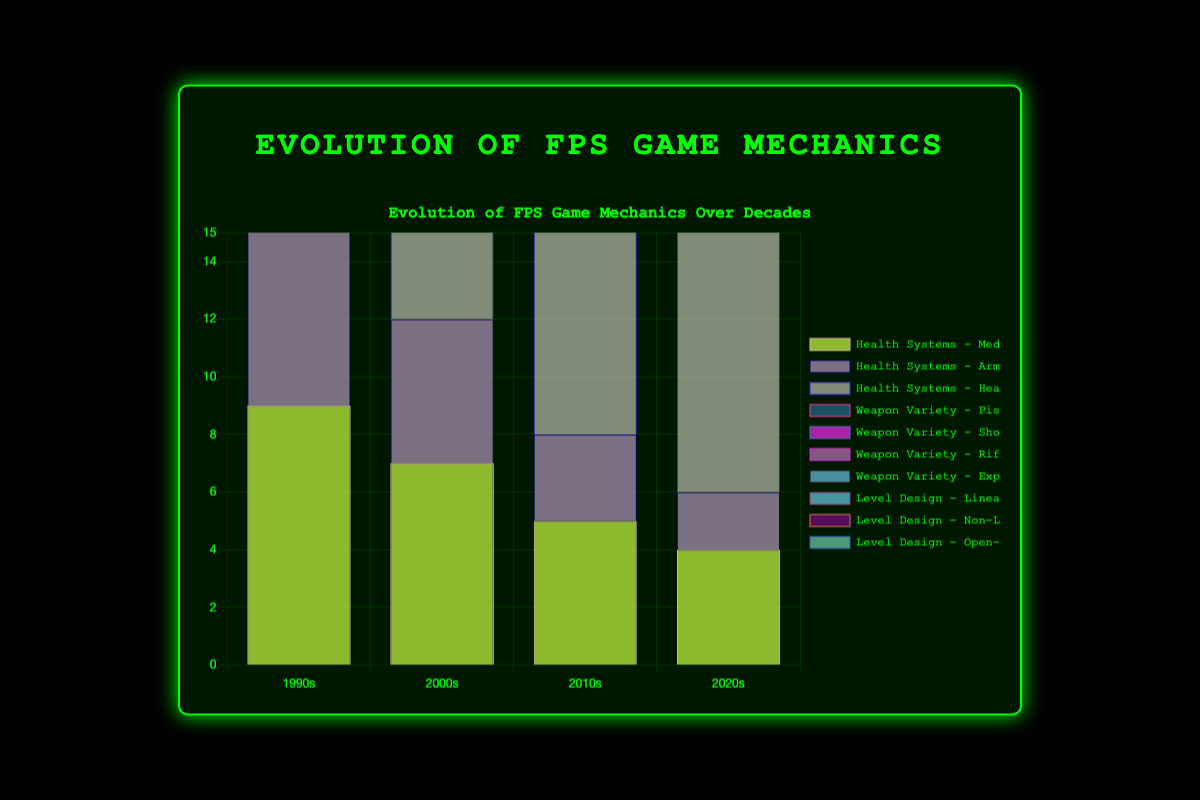Which decade saw the highest adoption of health regeneration? In the figure, the bar representing health regeneration increases across the decades and peaks in the 2020s.
Answer: 2020s How did the popularity of medkits change from the 1990s to the 2020s? In the figure, the height of the bars representing medkits decreases from the 1990s (9) to the 2020s (4).
Answer: Decreased Between the 1990s and 2020s, which health system category saw the most significant increase? The health regeneration bars grew from 2 in the 1990s to 12 in the 2020s, marking a substantial increase compared to medkits and armor pickups.
Answer: Health regeneration Compare the prevalence of non-linear level design in the 2010s and 2020s. The height of the bars for non-linear level design are 6 in the 2010s and 7 in the 2020s, showing a slight increase.
Answer: 2020s What is the total count of pistols and shotguns combined in the 2010s? Examine the 2010s decade for weapon variety, the bars for pistols (10) and shotguns (8) sum up to 18.
Answer: 18 Which decade had the least variety in explosives weapons? Check the height of the bars labeled explosives across each decade; the 1990s have the lowest count with 4.
Answer: 1990s Was open-world level design more popular in the 1990s or the 2000s? Compare the 'Open-World' bar heights for the mentioned decades; the 2000s have 2 while the 1990s have 1.
Answer: 2000s Calculate the average number of rifle varieties from the 1990s to the 2020s. Sum the rifle counts (5 + 7 + 8 + 9) and divide by the 4 decades, resulting in an average of 29/4 = 7.25.
Answer: 7.25 What is the difference in prevalence between linear and open-world level designs in the 2020s? Subtract the count for open-world (6) from linear (6), showing no difference.
Answer: 0 